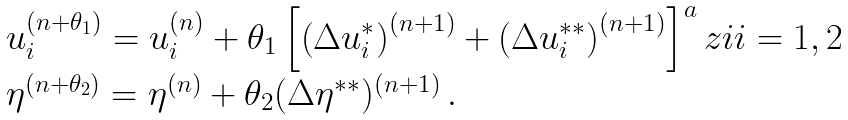<formula> <loc_0><loc_0><loc_500><loc_500>\begin{array} { l } u _ { i } ^ { ( n + \theta _ { 1 } ) } = u _ { i } ^ { ( n ) } + \theta _ { 1 } \left [ \left ( \Delta u _ { i } ^ { * } \right ) ^ { ( n + 1 ) } + \left ( \Delta u _ { i } ^ { * * } \right ) ^ { ( n + 1 ) } \right ] ^ { a } z i i = 1 , 2 \\ \eta ^ { ( n + \theta _ { 2 } ) } = \eta ^ { ( n ) } + \theta _ { 2 } ( \Delta \eta ^ { * * } ) ^ { ( n + 1 ) } \, . \end{array}</formula> 